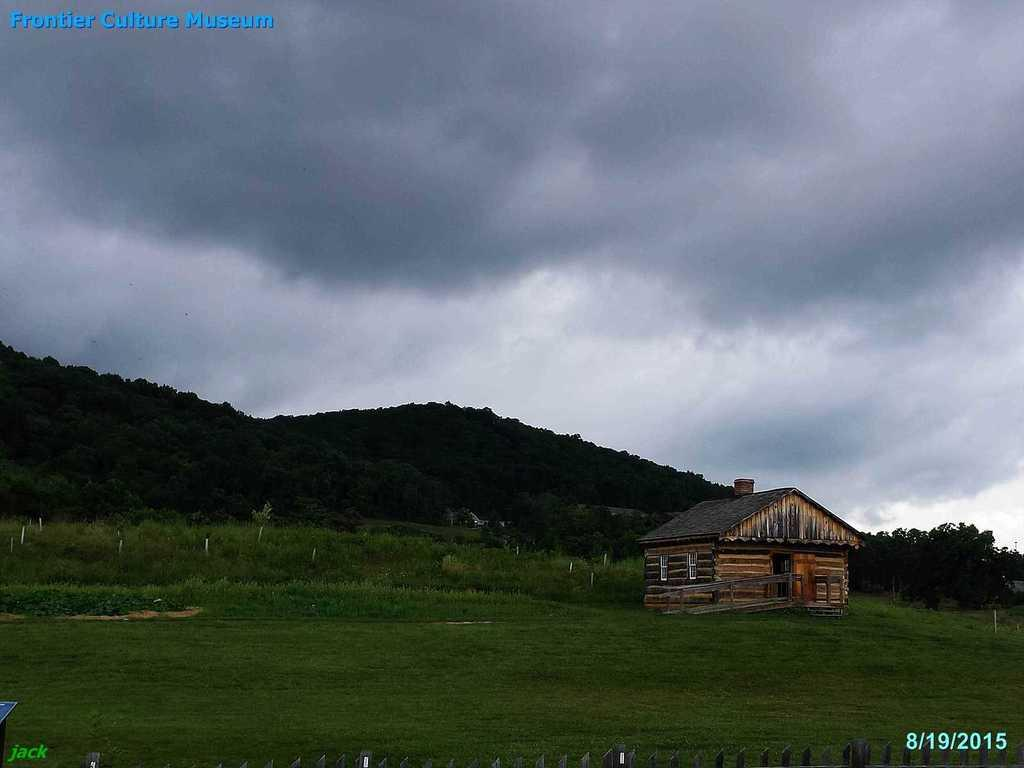What structure is located on the right side of the image? There is a shed on the right side of the image. What can be seen at the bottom of the image? There is a fence and grass at the bottom of the image. What type of landscape feature is visible in the background of the image? There are hills in the background of the image. What is visible in the sky in the background of the image? The sky is visible in the background of the image. Can you tell me how many police officers are guiding the traffic in the image? There are no police officers or traffic in the image; it features a shed, a fence, grass, hills, and the sky. What type of cloud is present in the image? There is no cloud present in the image; it features a shed, a fence, grass, hills, and the sky. 